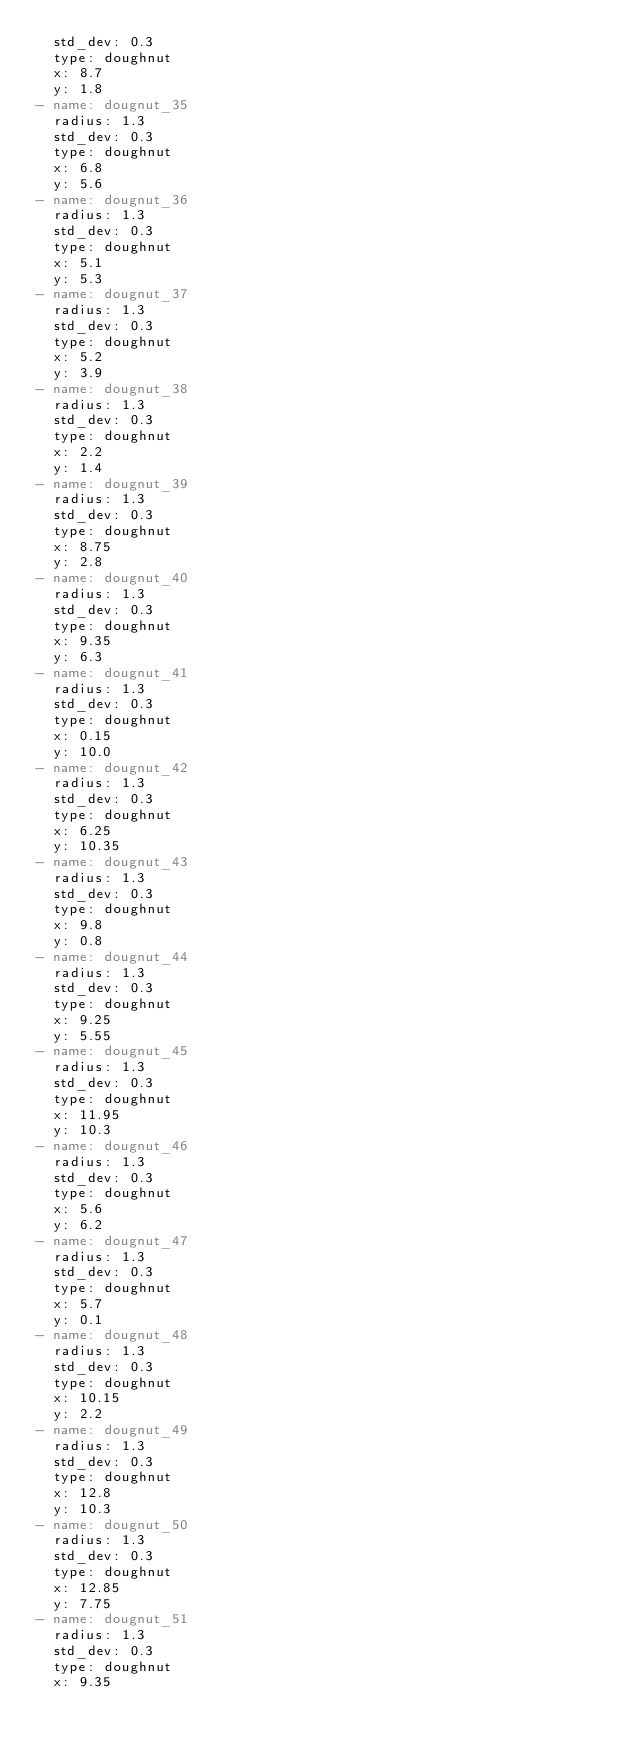<code> <loc_0><loc_0><loc_500><loc_500><_YAML_>  std_dev: 0.3
  type: doughnut
  x: 8.7
  y: 1.8
- name: dougnut_35
  radius: 1.3
  std_dev: 0.3
  type: doughnut
  x: 6.8
  y: 5.6
- name: dougnut_36
  radius: 1.3
  std_dev: 0.3
  type: doughnut
  x: 5.1
  y: 5.3
- name: dougnut_37
  radius: 1.3
  std_dev: 0.3
  type: doughnut
  x: 5.2
  y: 3.9
- name: dougnut_38
  radius: 1.3
  std_dev: 0.3
  type: doughnut
  x: 2.2
  y: 1.4
- name: dougnut_39
  radius: 1.3
  std_dev: 0.3
  type: doughnut
  x: 8.75
  y: 2.8
- name: dougnut_40
  radius: 1.3
  std_dev: 0.3
  type: doughnut
  x: 9.35
  y: 6.3
- name: dougnut_41
  radius: 1.3
  std_dev: 0.3
  type: doughnut
  x: 0.15
  y: 10.0
- name: dougnut_42
  radius: 1.3
  std_dev: 0.3
  type: doughnut
  x: 6.25
  y: 10.35
- name: dougnut_43
  radius: 1.3
  std_dev: 0.3
  type: doughnut
  x: 9.8
  y: 0.8
- name: dougnut_44
  radius: 1.3
  std_dev: 0.3
  type: doughnut
  x: 9.25
  y: 5.55
- name: dougnut_45
  radius: 1.3
  std_dev: 0.3
  type: doughnut
  x: 11.95
  y: 10.3
- name: dougnut_46
  radius: 1.3
  std_dev: 0.3
  type: doughnut
  x: 5.6
  y: 6.2
- name: dougnut_47
  radius: 1.3
  std_dev: 0.3
  type: doughnut
  x: 5.7
  y: 0.1
- name: dougnut_48
  radius: 1.3
  std_dev: 0.3
  type: doughnut
  x: 10.15
  y: 2.2
- name: dougnut_49
  radius: 1.3
  std_dev: 0.3
  type: doughnut
  x: 12.8
  y: 10.3
- name: dougnut_50
  radius: 1.3
  std_dev: 0.3
  type: doughnut
  x: 12.85
  y: 7.75
- name: dougnut_51
  radius: 1.3
  std_dev: 0.3
  type: doughnut
  x: 9.35</code> 